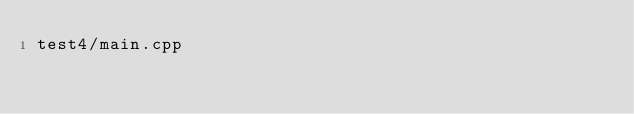Convert code to text. <code><loc_0><loc_0><loc_500><loc_500><_FORTRAN_>test4/main.cpp
</code> 